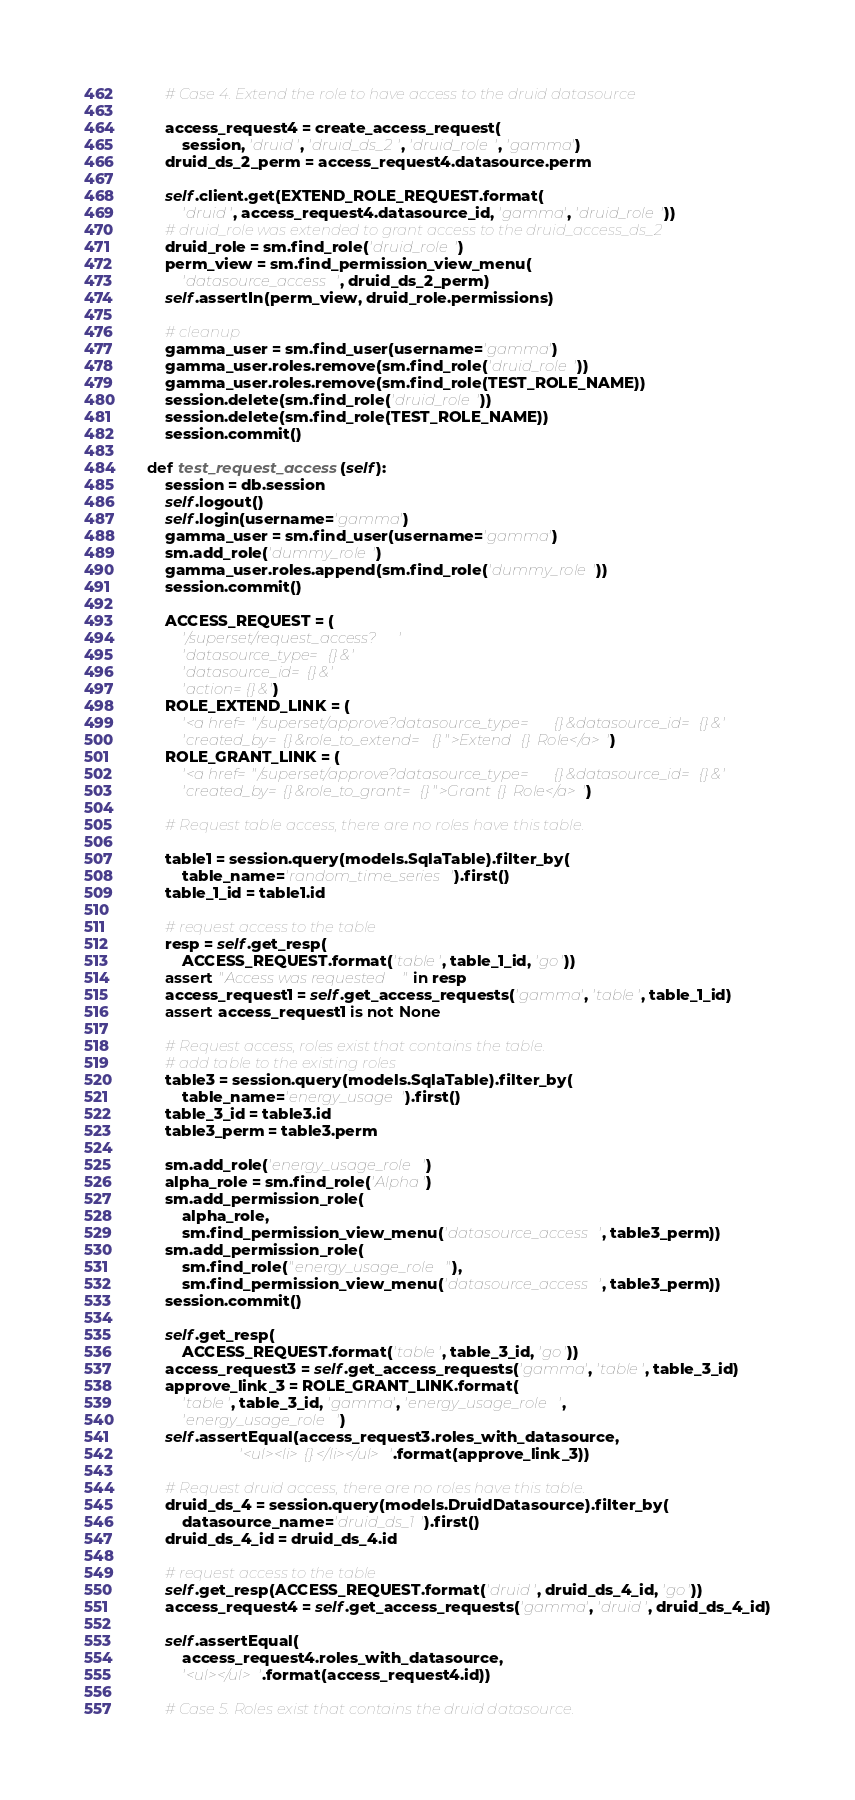<code> <loc_0><loc_0><loc_500><loc_500><_Python_>        # Case 4. Extend the role to have access to the druid datasource

        access_request4 = create_access_request(
            session, 'druid', 'druid_ds_2', 'druid_role', 'gamma')
        druid_ds_2_perm = access_request4.datasource.perm

        self.client.get(EXTEND_ROLE_REQUEST.format(
            'druid', access_request4.datasource_id, 'gamma', 'druid_role'))
        # druid_role was extended to grant access to the druid_access_ds_2
        druid_role = sm.find_role('druid_role')
        perm_view = sm.find_permission_view_menu(
            'datasource_access', druid_ds_2_perm)
        self.assertIn(perm_view, druid_role.permissions)

        # cleanup
        gamma_user = sm.find_user(username='gamma')
        gamma_user.roles.remove(sm.find_role('druid_role'))
        gamma_user.roles.remove(sm.find_role(TEST_ROLE_NAME))
        session.delete(sm.find_role('druid_role'))
        session.delete(sm.find_role(TEST_ROLE_NAME))
        session.commit()

    def test_request_access(self):
        session = db.session
        self.logout()
        self.login(username='gamma')
        gamma_user = sm.find_user(username='gamma')
        sm.add_role('dummy_role')
        gamma_user.roles.append(sm.find_role('dummy_role'))
        session.commit()

        ACCESS_REQUEST = (
            '/superset/request_access?'
            'datasource_type={}&'
            'datasource_id={}&'
            'action={}&')
        ROLE_EXTEND_LINK = (
            '<a href="/superset/approve?datasource_type={}&datasource_id={}&'
            'created_by={}&role_to_extend={}">Extend {} Role</a>')
        ROLE_GRANT_LINK = (
            '<a href="/superset/approve?datasource_type={}&datasource_id={}&'
            'created_by={}&role_to_grant={}">Grant {} Role</a>')

        # Request table access, there are no roles have this table.

        table1 = session.query(models.SqlaTable).filter_by(
            table_name='random_time_series').first()
        table_1_id = table1.id

        # request access to the table
        resp = self.get_resp(
            ACCESS_REQUEST.format('table', table_1_id, 'go'))
        assert "Access was requested" in resp
        access_request1 = self.get_access_requests('gamma', 'table', table_1_id)
        assert access_request1 is not None

        # Request access, roles exist that contains the table.
        # add table to the existing roles
        table3 = session.query(models.SqlaTable).filter_by(
            table_name='energy_usage').first()
        table_3_id = table3.id
        table3_perm = table3.perm

        sm.add_role('energy_usage_role')
        alpha_role = sm.find_role('Alpha')
        sm.add_permission_role(
            alpha_role,
            sm.find_permission_view_menu('datasource_access', table3_perm))
        sm.add_permission_role(
            sm.find_role("energy_usage_role"),
            sm.find_permission_view_menu('datasource_access', table3_perm))
        session.commit()

        self.get_resp(
            ACCESS_REQUEST.format('table', table_3_id, 'go'))
        access_request3 = self.get_access_requests('gamma', 'table', table_3_id)
        approve_link_3 = ROLE_GRANT_LINK.format(
            'table', table_3_id, 'gamma', 'energy_usage_role',
            'energy_usage_role')
        self.assertEqual(access_request3.roles_with_datasource,
                         '<ul><li>{}</li></ul>'.format(approve_link_3))

        # Request druid access, there are no roles have this table.
        druid_ds_4 = session.query(models.DruidDatasource).filter_by(
            datasource_name='druid_ds_1').first()
        druid_ds_4_id = druid_ds_4.id

        # request access to the table
        self.get_resp(ACCESS_REQUEST.format('druid', druid_ds_4_id, 'go'))
        access_request4 = self.get_access_requests('gamma', 'druid', druid_ds_4_id)

        self.assertEqual(
            access_request4.roles_with_datasource,
            '<ul></ul>'.format(access_request4.id))

        # Case 5. Roles exist that contains the druid datasource.</code> 